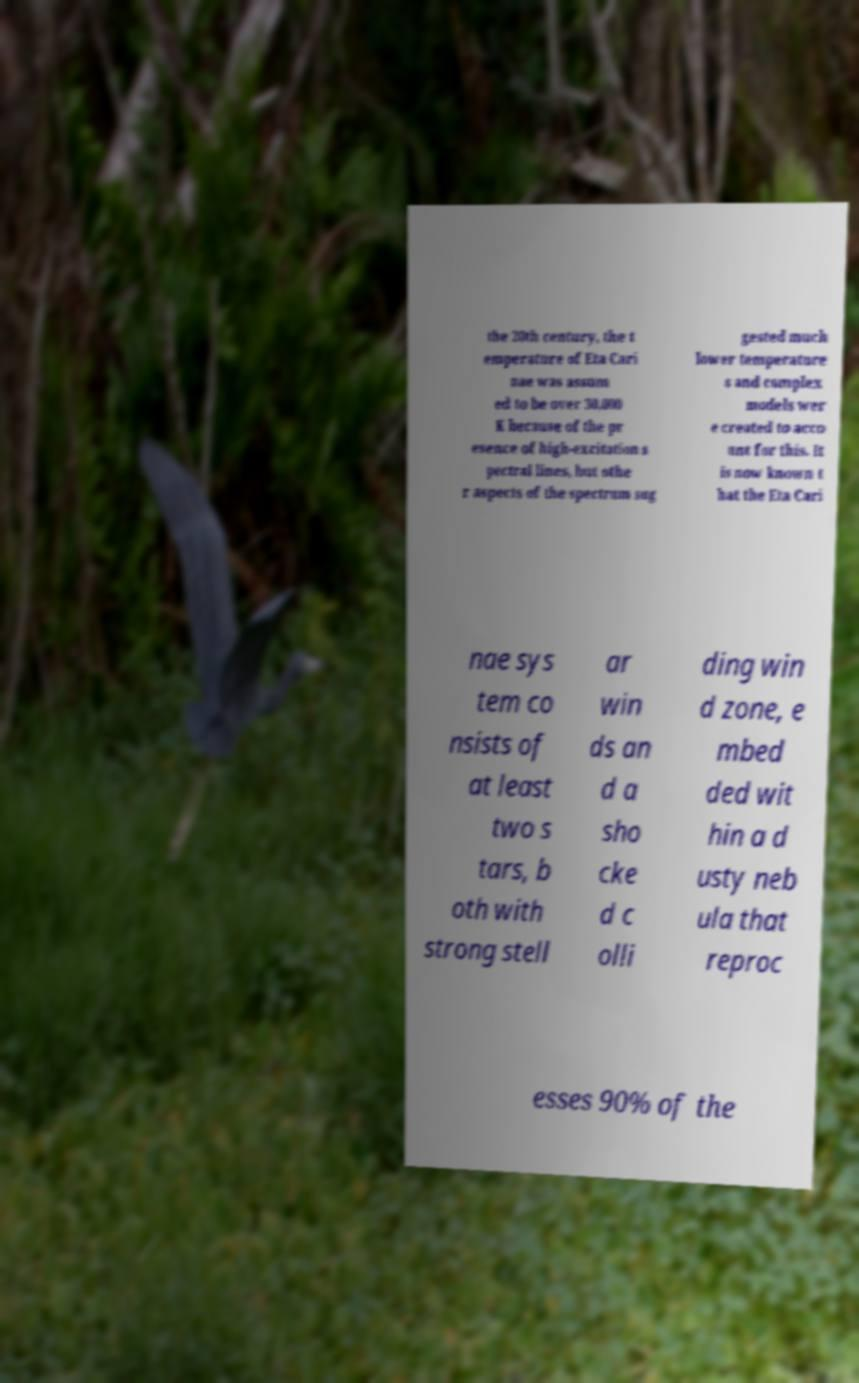Could you extract and type out the text from this image? the 20th century, the t emperature of Eta Cari nae was assum ed to be over 30,000 K because of the pr esence of high-excitation s pectral lines, but othe r aspects of the spectrum sug gested much lower temperature s and complex models wer e created to acco unt for this. It is now known t hat the Eta Cari nae sys tem co nsists of at least two s tars, b oth with strong stell ar win ds an d a sho cke d c olli ding win d zone, e mbed ded wit hin a d usty neb ula that reproc esses 90% of the 